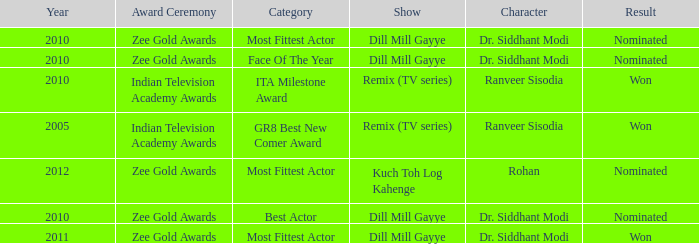Which character was nominated in the 2010 Indian Television Academy Awards? Ranveer Sisodia. 